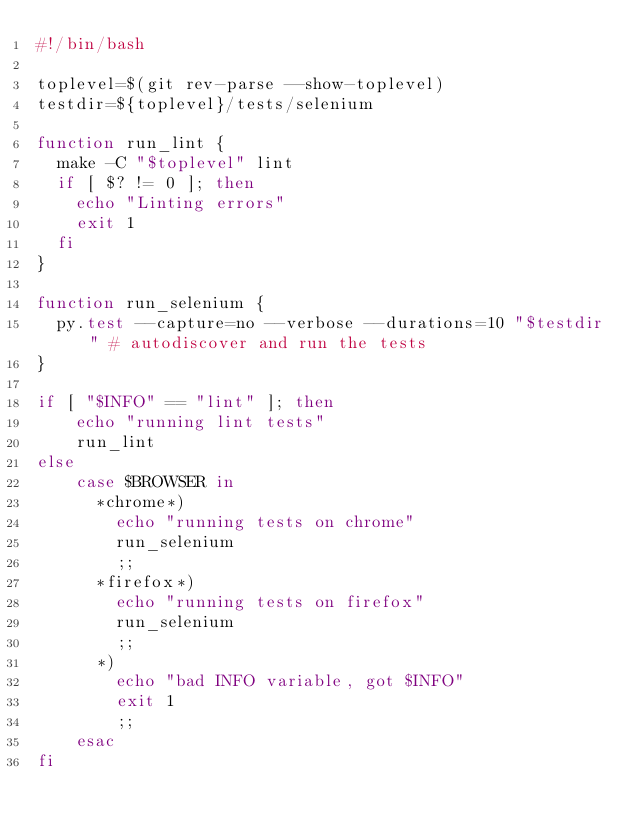<code> <loc_0><loc_0><loc_500><loc_500><_Bash_>#!/bin/bash

toplevel=$(git rev-parse --show-toplevel)
testdir=${toplevel}/tests/selenium

function run_lint {
  make -C "$toplevel" lint
  if [ $? != 0 ]; then
    echo "Linting errors"
    exit 1
  fi
}

function run_selenium {
  py.test --capture=no --verbose --durations=10 "$testdir" # autodiscover and run the tests
}

if [ "$INFO" == "lint" ]; then
    echo "running lint tests"
    run_lint
else
    case $BROWSER in
      *chrome*)
        echo "running tests on chrome"
        run_selenium
        ;;
      *firefox*)
        echo "running tests on firefox"
        run_selenium
        ;;
      *)
        echo "bad INFO variable, got $INFO"
        exit 1
        ;;
    esac
fi
</code> 